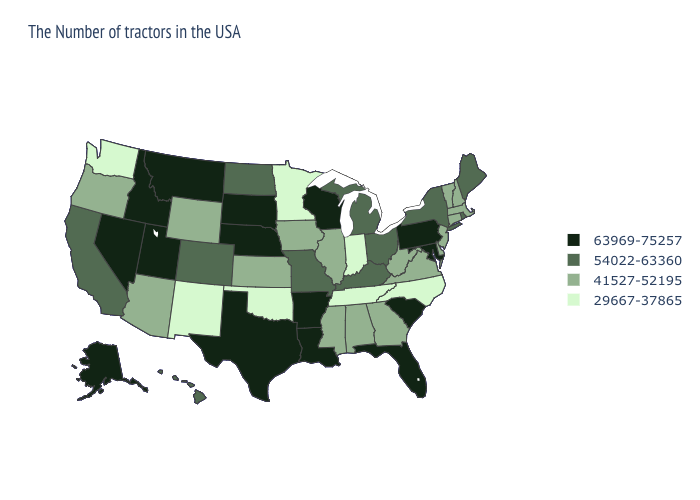Name the states that have a value in the range 54022-63360?
Be succinct. Maine, Rhode Island, New York, Ohio, Michigan, Kentucky, Missouri, North Dakota, Colorado, California, Hawaii. What is the value of New Hampshire?
Write a very short answer. 41527-52195. Does Minnesota have a lower value than New Mexico?
Be succinct. No. Which states have the lowest value in the USA?
Keep it brief. North Carolina, Indiana, Tennessee, Minnesota, Oklahoma, New Mexico, Washington. Does Washington have the lowest value in the USA?
Concise answer only. Yes. Name the states that have a value in the range 54022-63360?
Short answer required. Maine, Rhode Island, New York, Ohio, Michigan, Kentucky, Missouri, North Dakota, Colorado, California, Hawaii. What is the value of Colorado?
Concise answer only. 54022-63360. Does New Hampshire have the lowest value in the Northeast?
Keep it brief. Yes. Which states have the lowest value in the MidWest?
Quick response, please. Indiana, Minnesota. What is the lowest value in the USA?
Quick response, please. 29667-37865. Name the states that have a value in the range 63969-75257?
Concise answer only. Maryland, Pennsylvania, South Carolina, Florida, Wisconsin, Louisiana, Arkansas, Nebraska, Texas, South Dakota, Utah, Montana, Idaho, Nevada, Alaska. Does Colorado have the lowest value in the USA?
Give a very brief answer. No. Does Iowa have the same value as Maryland?
Write a very short answer. No. Does Alabama have a higher value than South Dakota?
Quick response, please. No. Is the legend a continuous bar?
Short answer required. No. 